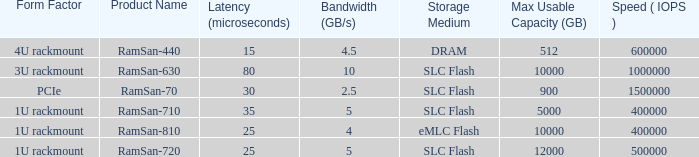What is the read/write operations per second for the emlc flash? 400000.0. 